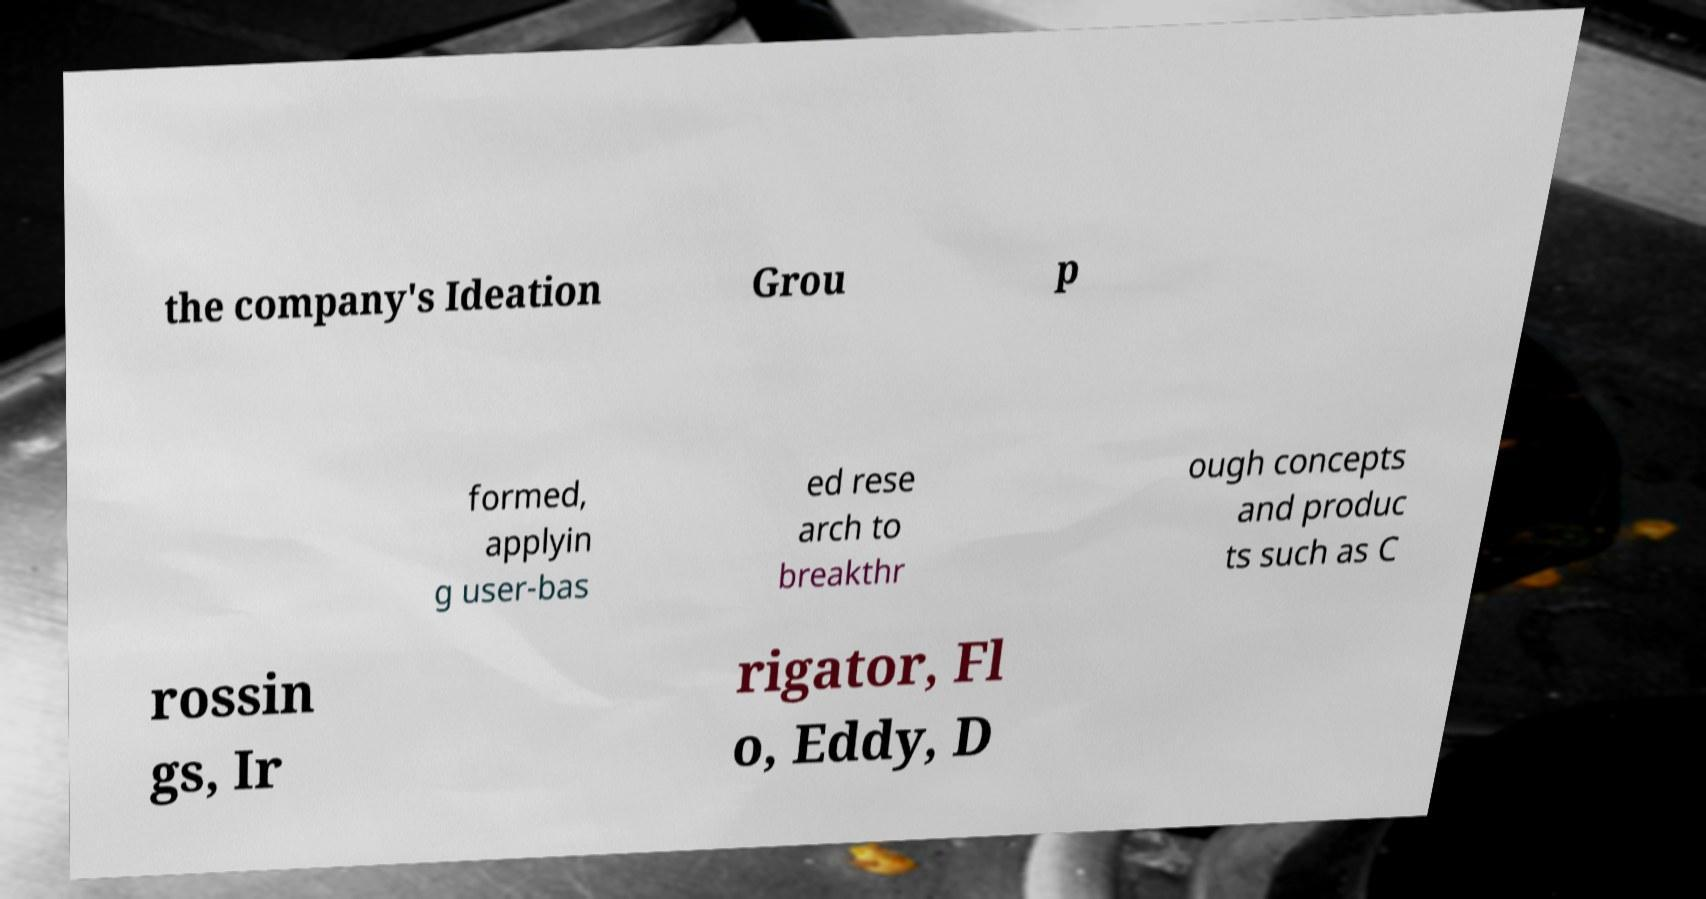I need the written content from this picture converted into text. Can you do that? the company's Ideation Grou p formed, applyin g user-bas ed rese arch to breakthr ough concepts and produc ts such as C rossin gs, Ir rigator, Fl o, Eddy, D 